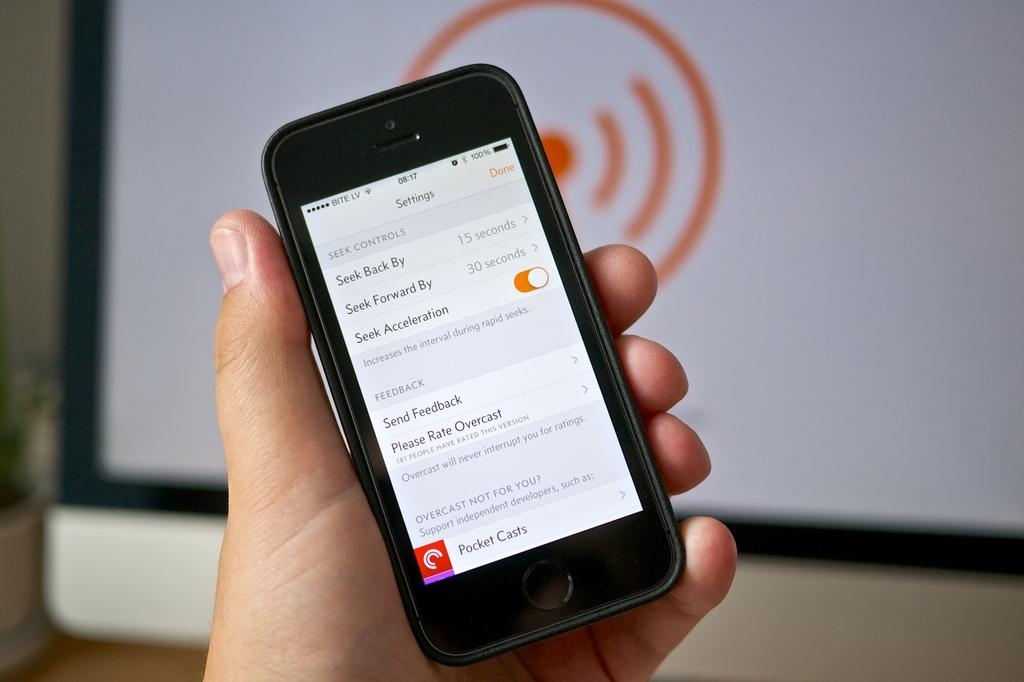<image>
Write a terse but informative summary of the picture. A mobile phone showing the settings screen for the Overcast application. 